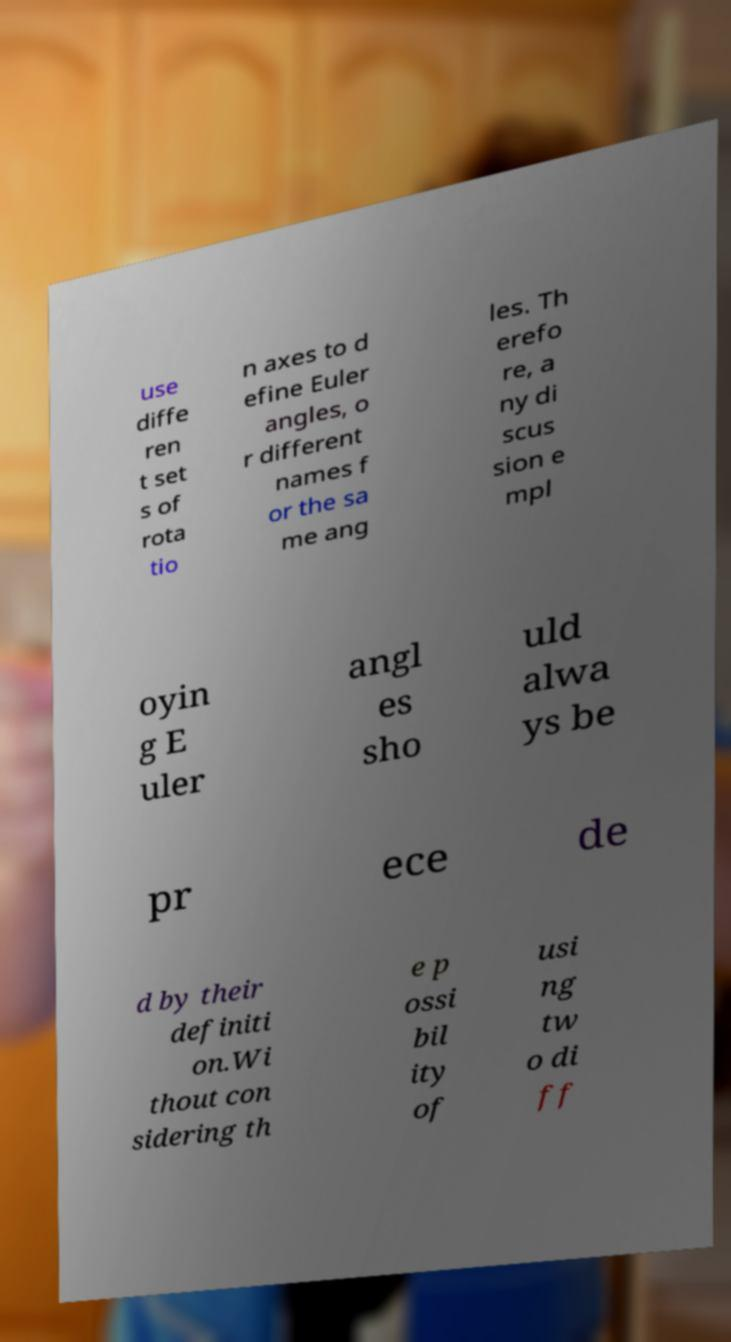What messages or text are displayed in this image? I need them in a readable, typed format. use diffe ren t set s of rota tio n axes to d efine Euler angles, o r different names f or the sa me ang les. Th erefo re, a ny di scus sion e mpl oyin g E uler angl es sho uld alwa ys be pr ece de d by their definiti on.Wi thout con sidering th e p ossi bil ity of usi ng tw o di ff 